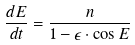Convert formula to latex. <formula><loc_0><loc_0><loc_500><loc_500>\frac { d E } { d t } = \frac { n } { 1 - \epsilon \cdot \cos E }</formula> 